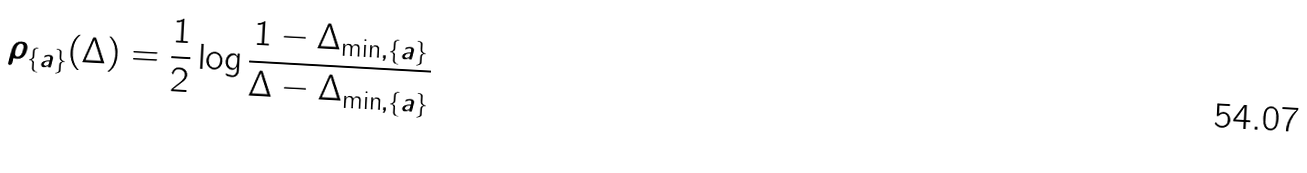Convert formula to latex. <formula><loc_0><loc_0><loc_500><loc_500>\rho _ { \{ a \} } ( \Delta ) = \frac { 1 } { 2 } \log \frac { 1 - \Delta _ { \min , \{ a \} } } { \Delta - \Delta _ { \min , \{ a \} } }</formula> 